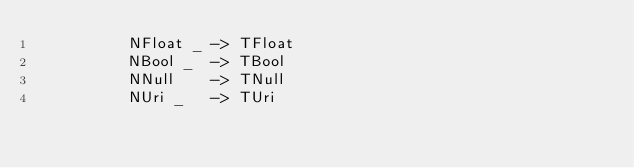Convert code to text. <code><loc_0><loc_0><loc_500><loc_500><_Haskell_>          NFloat _ -> TFloat
          NBool _  -> TBool
          NNull    -> TNull
          NUri _   -> TUri
</code> 